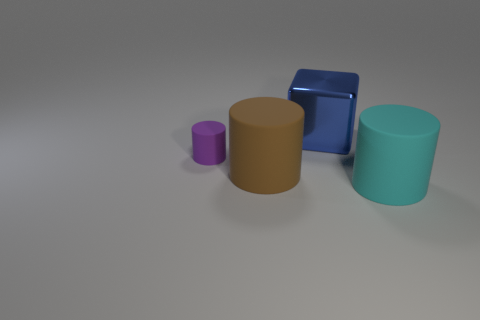Add 2 small matte things. How many objects exist? 6 Subtract all cylinders. How many objects are left? 1 Add 3 matte things. How many matte things exist? 6 Subtract 0 purple cubes. How many objects are left? 4 Subtract all big blue cylinders. Subtract all metallic objects. How many objects are left? 3 Add 3 tiny cylinders. How many tiny cylinders are left? 4 